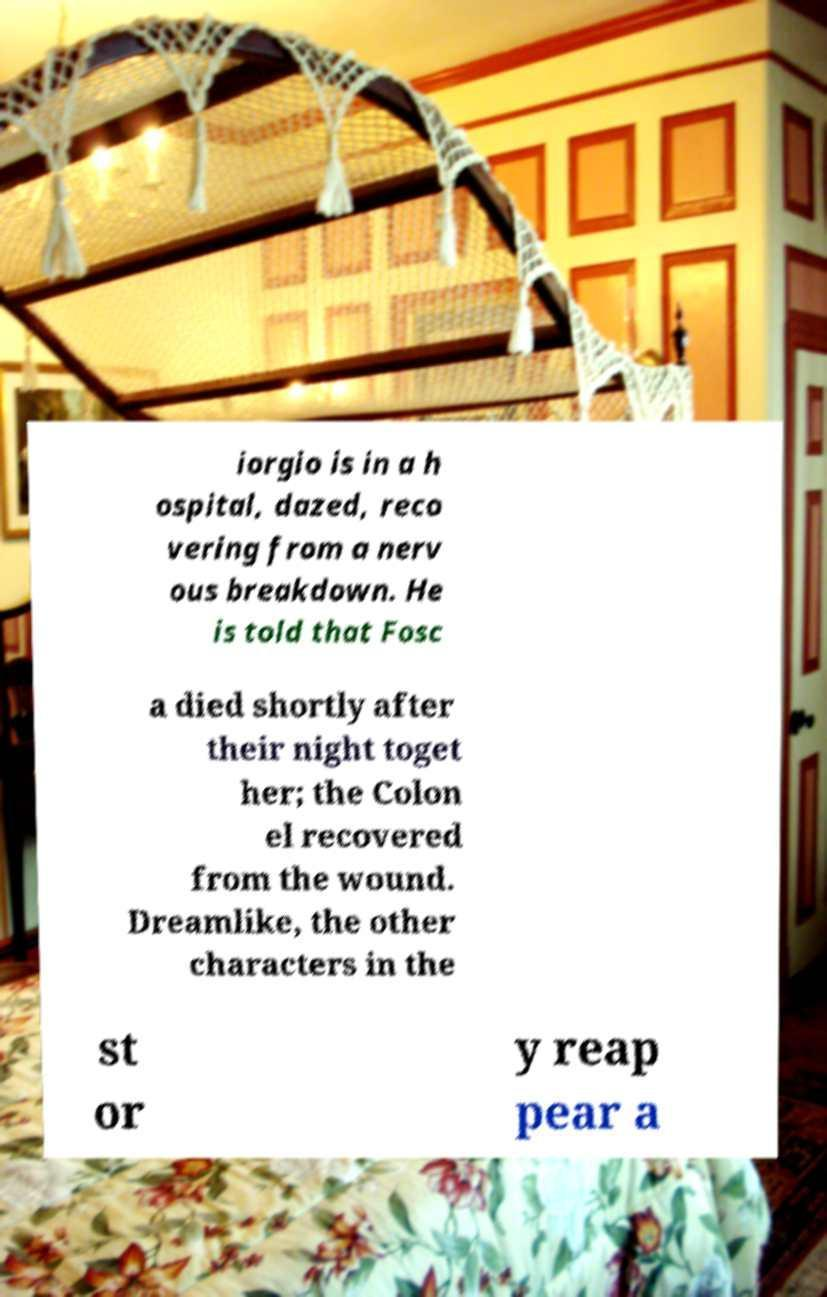I need the written content from this picture converted into text. Can you do that? iorgio is in a h ospital, dazed, reco vering from a nerv ous breakdown. He is told that Fosc a died shortly after their night toget her; the Colon el recovered from the wound. Dreamlike, the other characters in the st or y reap pear a 